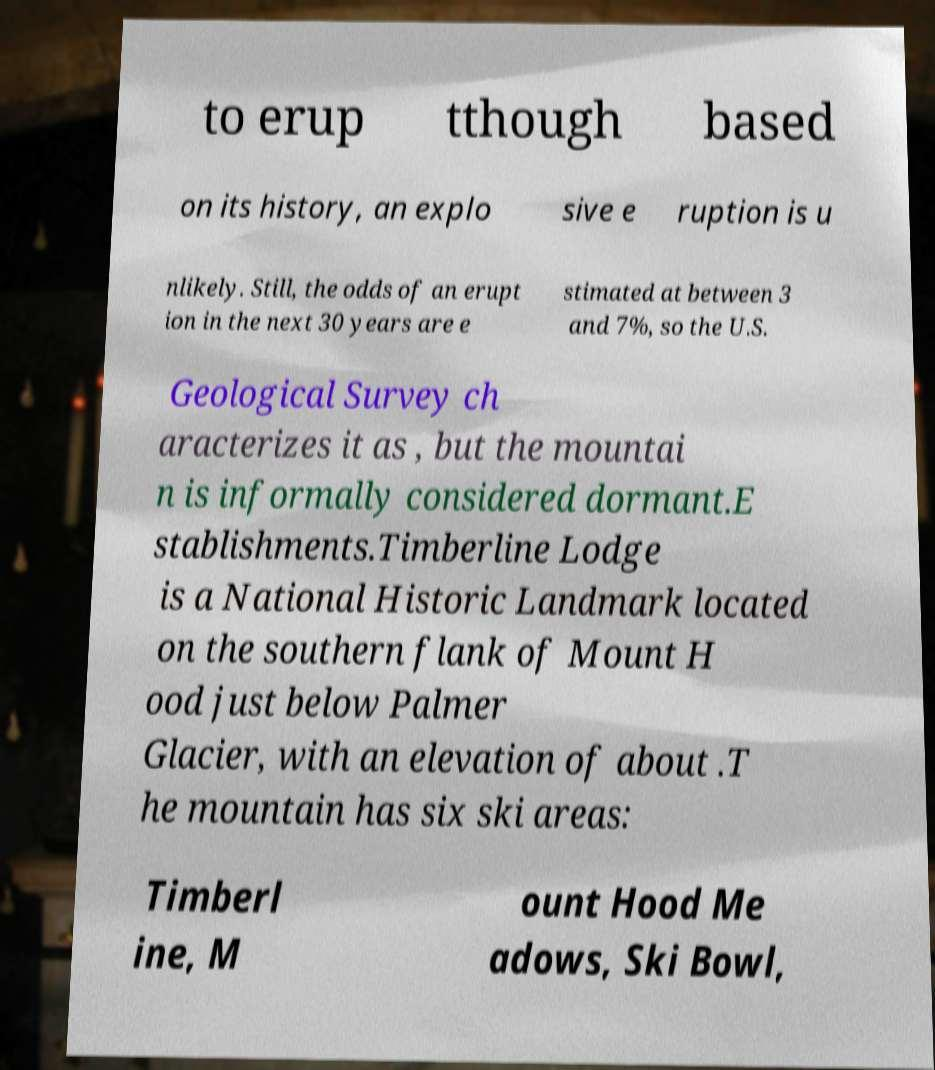There's text embedded in this image that I need extracted. Can you transcribe it verbatim? to erup tthough based on its history, an explo sive e ruption is u nlikely. Still, the odds of an erupt ion in the next 30 years are e stimated at between 3 and 7%, so the U.S. Geological Survey ch aracterizes it as , but the mountai n is informally considered dormant.E stablishments.Timberline Lodge is a National Historic Landmark located on the southern flank of Mount H ood just below Palmer Glacier, with an elevation of about .T he mountain has six ski areas: Timberl ine, M ount Hood Me adows, Ski Bowl, 